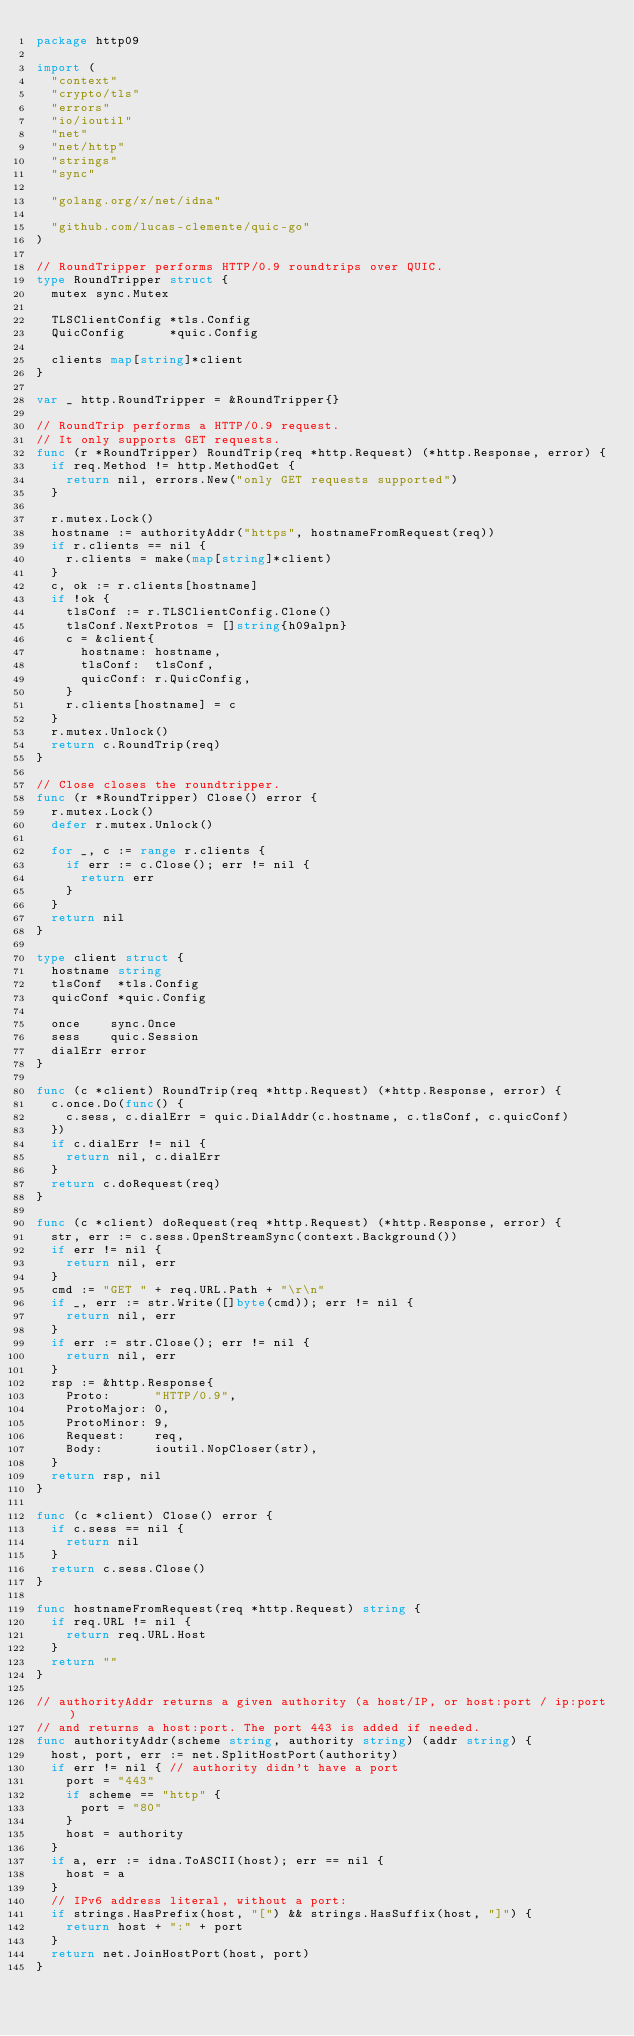Convert code to text. <code><loc_0><loc_0><loc_500><loc_500><_Go_>package http09

import (
	"context"
	"crypto/tls"
	"errors"
	"io/ioutil"
	"net"
	"net/http"
	"strings"
	"sync"

	"golang.org/x/net/idna"

	"github.com/lucas-clemente/quic-go"
)

// RoundTripper performs HTTP/0.9 roundtrips over QUIC.
type RoundTripper struct {
	mutex sync.Mutex

	TLSClientConfig *tls.Config
	QuicConfig      *quic.Config

	clients map[string]*client
}

var _ http.RoundTripper = &RoundTripper{}

// RoundTrip performs a HTTP/0.9 request.
// It only supports GET requests.
func (r *RoundTripper) RoundTrip(req *http.Request) (*http.Response, error) {
	if req.Method != http.MethodGet {
		return nil, errors.New("only GET requests supported")
	}

	r.mutex.Lock()
	hostname := authorityAddr("https", hostnameFromRequest(req))
	if r.clients == nil {
		r.clients = make(map[string]*client)
	}
	c, ok := r.clients[hostname]
	if !ok {
		tlsConf := r.TLSClientConfig.Clone()
		tlsConf.NextProtos = []string{h09alpn}
		c = &client{
			hostname: hostname,
			tlsConf:  tlsConf,
			quicConf: r.QuicConfig,
		}
		r.clients[hostname] = c
	}
	r.mutex.Unlock()
	return c.RoundTrip(req)
}

// Close closes the roundtripper.
func (r *RoundTripper) Close() error {
	r.mutex.Lock()
	defer r.mutex.Unlock()

	for _, c := range r.clients {
		if err := c.Close(); err != nil {
			return err
		}
	}
	return nil
}

type client struct {
	hostname string
	tlsConf  *tls.Config
	quicConf *quic.Config

	once    sync.Once
	sess    quic.Session
	dialErr error
}

func (c *client) RoundTrip(req *http.Request) (*http.Response, error) {
	c.once.Do(func() {
		c.sess, c.dialErr = quic.DialAddr(c.hostname, c.tlsConf, c.quicConf)
	})
	if c.dialErr != nil {
		return nil, c.dialErr
	}
	return c.doRequest(req)
}

func (c *client) doRequest(req *http.Request) (*http.Response, error) {
	str, err := c.sess.OpenStreamSync(context.Background())
	if err != nil {
		return nil, err
	}
	cmd := "GET " + req.URL.Path + "\r\n"
	if _, err := str.Write([]byte(cmd)); err != nil {
		return nil, err
	}
	if err := str.Close(); err != nil {
		return nil, err
	}
	rsp := &http.Response{
		Proto:      "HTTP/0.9",
		ProtoMajor: 0,
		ProtoMinor: 9,
		Request:    req,
		Body:       ioutil.NopCloser(str),
	}
	return rsp, nil
}

func (c *client) Close() error {
	if c.sess == nil {
		return nil
	}
	return c.sess.Close()
}

func hostnameFromRequest(req *http.Request) string {
	if req.URL != nil {
		return req.URL.Host
	}
	return ""
}

// authorityAddr returns a given authority (a host/IP, or host:port / ip:port)
// and returns a host:port. The port 443 is added if needed.
func authorityAddr(scheme string, authority string) (addr string) {
	host, port, err := net.SplitHostPort(authority)
	if err != nil { // authority didn't have a port
		port = "443"
		if scheme == "http" {
			port = "80"
		}
		host = authority
	}
	if a, err := idna.ToASCII(host); err == nil {
		host = a
	}
	// IPv6 address literal, without a port:
	if strings.HasPrefix(host, "[") && strings.HasSuffix(host, "]") {
		return host + ":" + port
	}
	return net.JoinHostPort(host, port)
}
</code> 